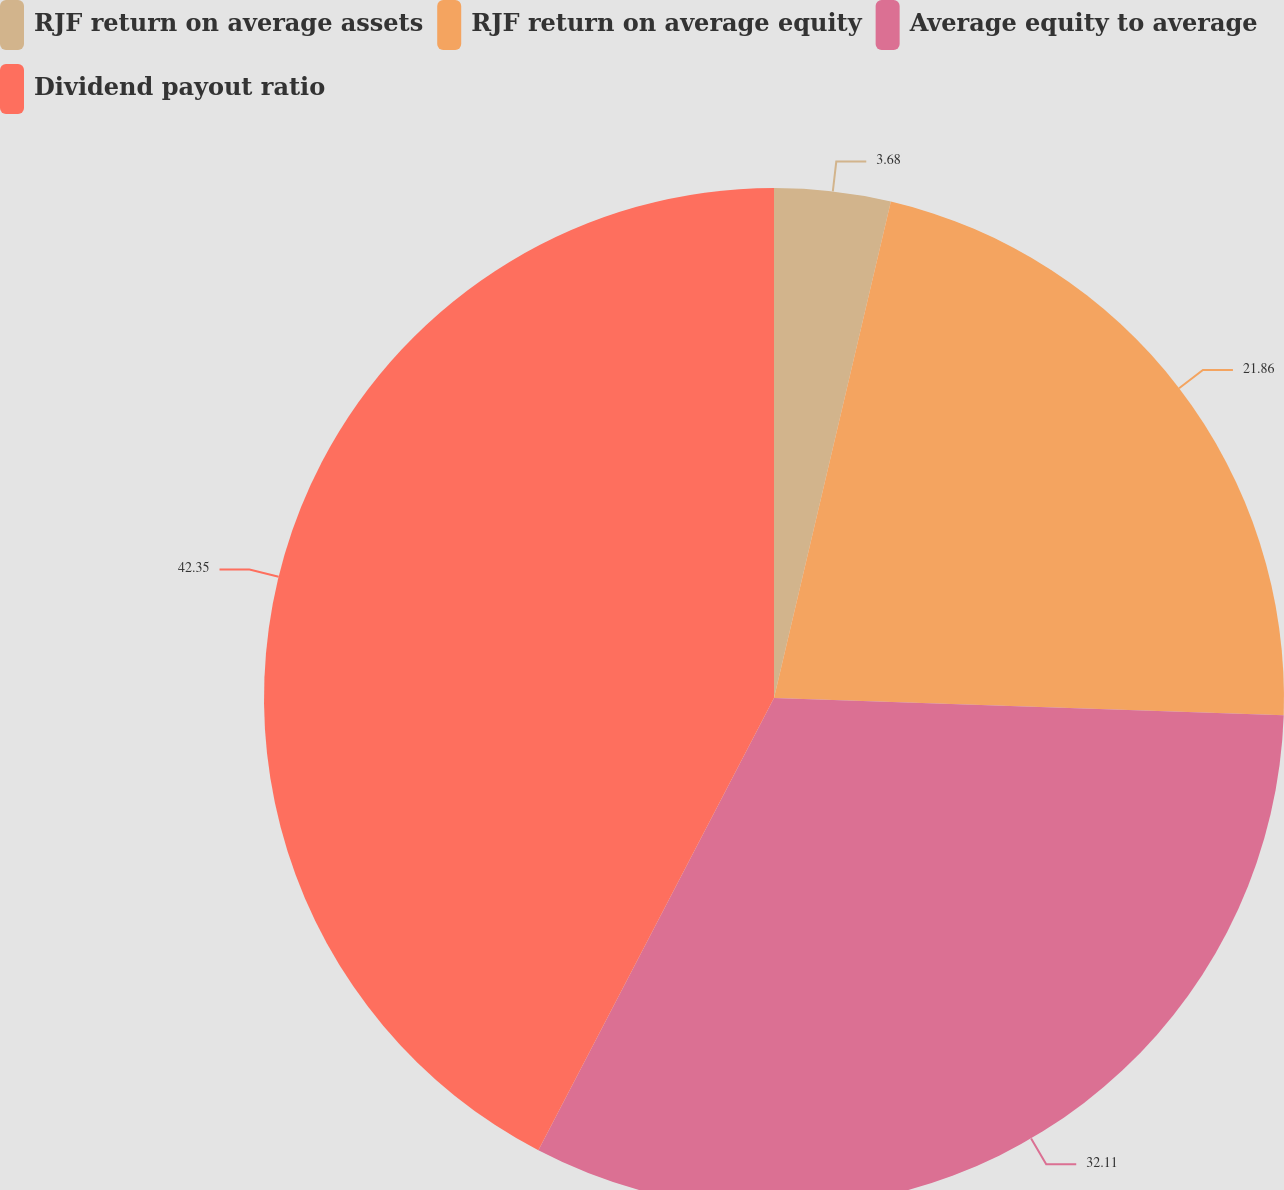<chart> <loc_0><loc_0><loc_500><loc_500><pie_chart><fcel>RJF return on average assets<fcel>RJF return on average equity<fcel>Average equity to average<fcel>Dividend payout ratio<nl><fcel>3.68%<fcel>21.86%<fcel>32.11%<fcel>42.36%<nl></chart> 